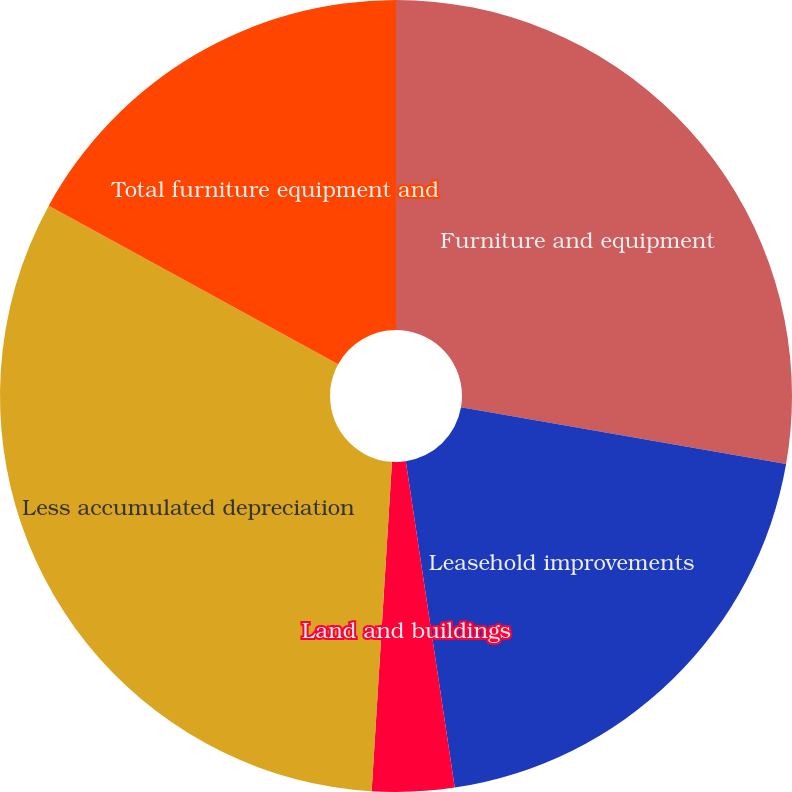Convert chart. <chart><loc_0><loc_0><loc_500><loc_500><pie_chart><fcel>Furniture and equipment<fcel>Leasehold improvements<fcel>Land and buildings<fcel>Less accumulated depreciation<fcel>Total furniture equipment and<nl><fcel>27.75%<fcel>19.88%<fcel>3.35%<fcel>32.0%<fcel>17.02%<nl></chart> 